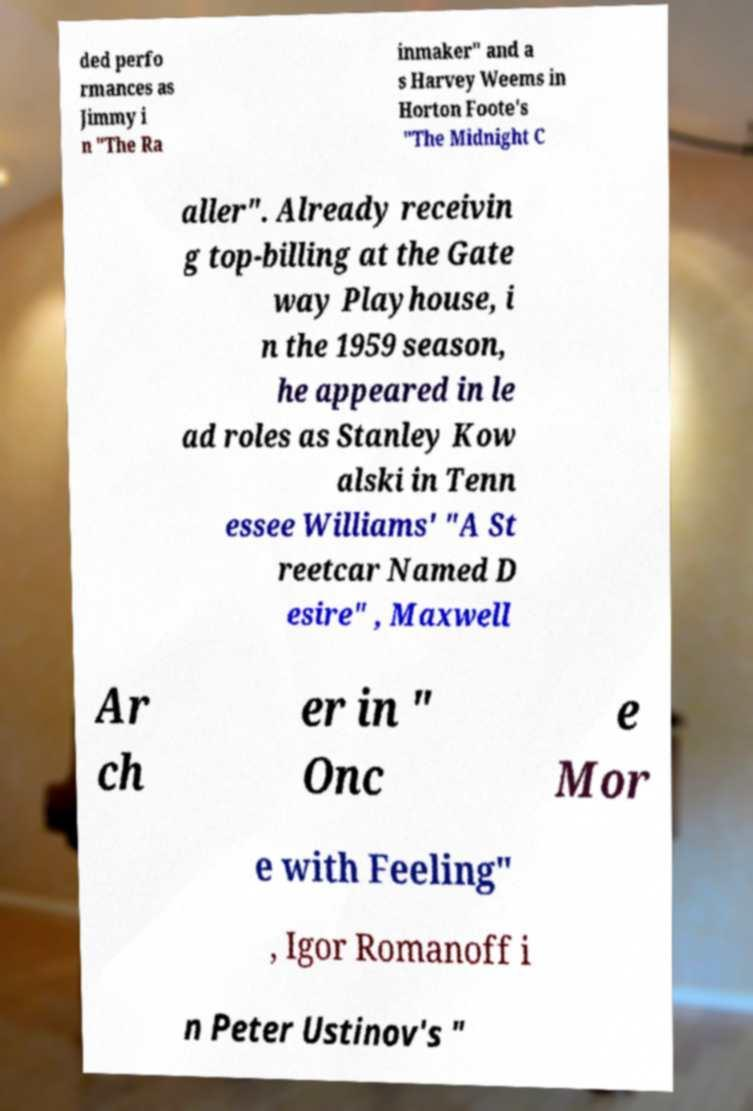Can you accurately transcribe the text from the provided image for me? ded perfo rmances as Jimmy i n "The Ra inmaker" and a s Harvey Weems in Horton Foote's "The Midnight C aller". Already receivin g top-billing at the Gate way Playhouse, i n the 1959 season, he appeared in le ad roles as Stanley Kow alski in Tenn essee Williams' "A St reetcar Named D esire" , Maxwell Ar ch er in " Onc e Mor e with Feeling" , Igor Romanoff i n Peter Ustinov's " 